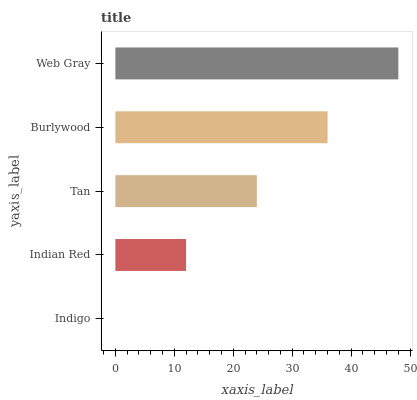Is Indigo the minimum?
Answer yes or no. Yes. Is Web Gray the maximum?
Answer yes or no. Yes. Is Indian Red the minimum?
Answer yes or no. No. Is Indian Red the maximum?
Answer yes or no. No. Is Indian Red greater than Indigo?
Answer yes or no. Yes. Is Indigo less than Indian Red?
Answer yes or no. Yes. Is Indigo greater than Indian Red?
Answer yes or no. No. Is Indian Red less than Indigo?
Answer yes or no. No. Is Tan the high median?
Answer yes or no. Yes. Is Tan the low median?
Answer yes or no. Yes. Is Indigo the high median?
Answer yes or no. No. Is Web Gray the low median?
Answer yes or no. No. 